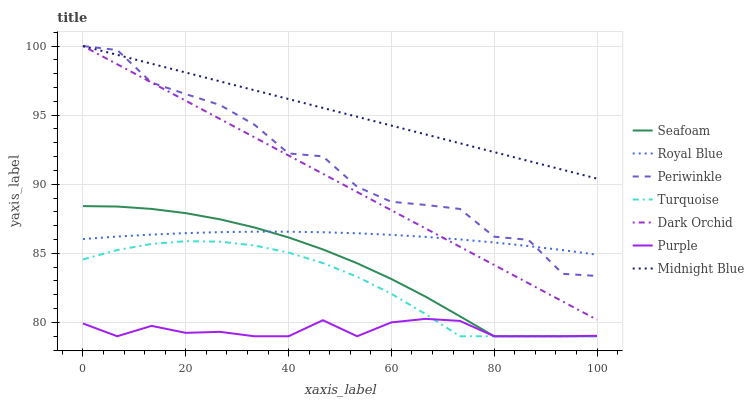Does Midnight Blue have the minimum area under the curve?
Answer yes or no. No. Does Purple have the maximum area under the curve?
Answer yes or no. No. Is Midnight Blue the smoothest?
Answer yes or no. No. Is Midnight Blue the roughest?
Answer yes or no. No. Does Midnight Blue have the lowest value?
Answer yes or no. No. Does Purple have the highest value?
Answer yes or no. No. Is Turquoise less than Midnight Blue?
Answer yes or no. Yes. Is Periwinkle greater than Purple?
Answer yes or no. Yes. Does Turquoise intersect Midnight Blue?
Answer yes or no. No. 